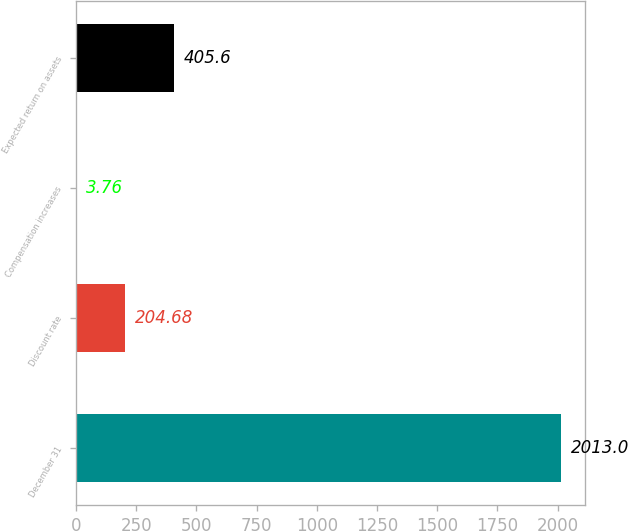<chart> <loc_0><loc_0><loc_500><loc_500><bar_chart><fcel>December 31<fcel>Discount rate<fcel>Compensation increases<fcel>Expected return on assets<nl><fcel>2013<fcel>204.68<fcel>3.76<fcel>405.6<nl></chart> 